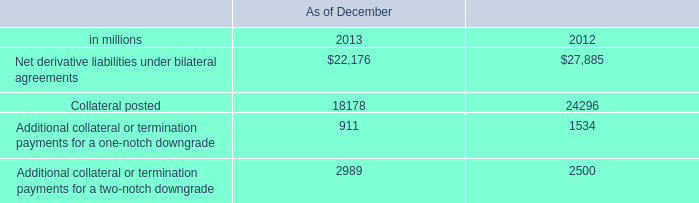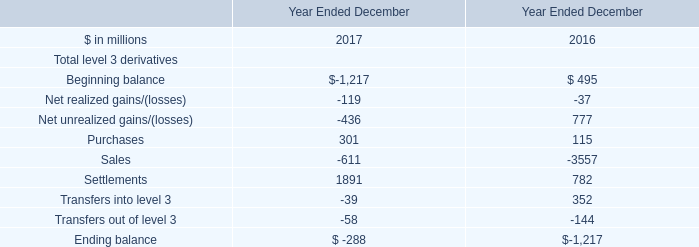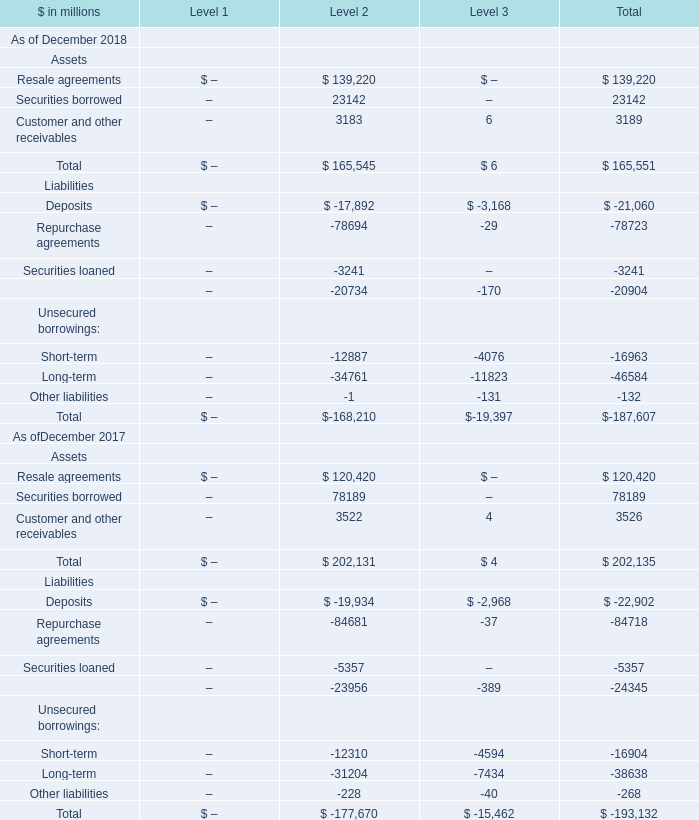What is the average amount of Resale agreements Assets of Level 2 is, and Beginning balance of Year Ended December 2017 ? 
Computations: ((120420.0 + 1217.0) / 2)
Answer: 60818.5. 